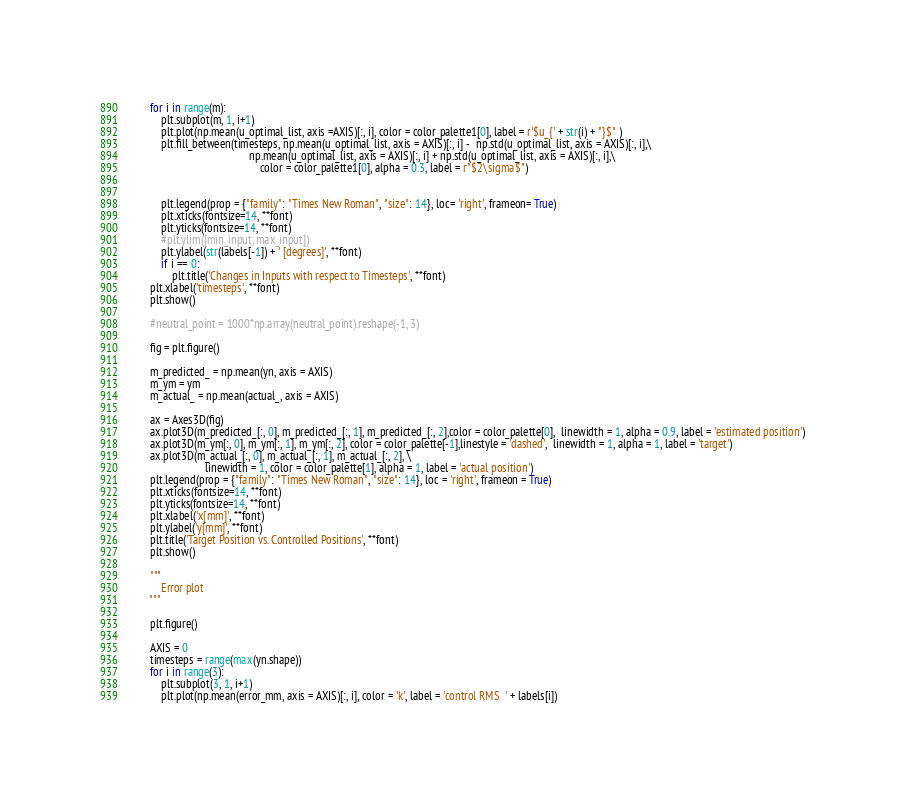Convert code to text. <code><loc_0><loc_0><loc_500><loc_500><_Python_>        for i in range(m):
            plt.subplot(m, 1, i+1)
            plt.plot(np.mean(u_optimal_list, axis =AXIS)[:, i], color = color_palette1[0], label = r'$u_{' + str(i) + "}$" )
            plt.fill_between(timesteps, np.mean(u_optimal_list, axis = AXIS)[:, i] -  np.std(u_optimal_list, axis = AXIS)[:, i],\
                                            np.mean(u_optimal_list, axis = AXIS)[:, i] + np.std(u_optimal_list, axis = AXIS)[:, i],\
                                                color = color_palette1[0], alpha = 0.3, label = r"$2\sigma$")


            plt.legend(prop = {"family": "Times New Roman", "size": 14}, loc= 'right', frameon= True)
            plt.xticks(fontsize=14, **font)
            plt.yticks(fontsize=14, **font)
            #plt.ylim([min_input, max_input])
            plt.ylabel(str(labels[-1]) + ' [degrees]', **font)
            if i == 0:
                plt.title('Changes in Inputs with respect to Timesteps', **font)
        plt.xlabel('timesteps', **font)
        plt.show()

        #neutral_point = 1000*np.array(neutral_point).reshape(-1, 3)

        fig = plt.figure()

        m_predicted_ = np.mean(yn, axis = AXIS)
        m_ym = ym
        m_actual_ = np.mean(actual_, axis = AXIS)

        ax = Axes3D(fig)
        ax.plot3D(m_predicted_[:, 0], m_predicted_[:, 1], m_predicted_[:, 2],color = color_palette[0],  linewidth = 1, alpha = 0.9, label = 'estimated position')
        ax.plot3D(m_ym[:, 0], m_ym[:, 1], m_ym[:, 2], color = color_palette[-1],linestyle = 'dashed',  linewidth = 1, alpha = 1, label = 'target')
        ax.plot3D(m_actual_[:, 0], m_actual_[:, 1], m_actual_[:, 2], \
                            linewidth = 1, color = color_palette[1], alpha = 1, label = 'actual position')
        plt.legend(prop = {"family": "Times New Roman", "size": 14}, loc = 'right', frameon = True)
        plt.xticks(fontsize=14, **font)
        plt.yticks(fontsize=14, **font)
        plt.xlabel('x[mm]', **font)
        plt.ylabel('y[mm]', **font)
        plt.title('Target Position vs. Controlled Positions', **font)
        plt.show()

        """
            Error plot
        """

        plt.figure()

        AXIS = 0
        timesteps = range(max(yn.shape))
        for i in range(3):
            plt.subplot(3, 1, i+1)
            plt.plot(np.mean(error_mm, axis = AXIS)[:, i], color = 'k', label = 'control RMS  ' + labels[i])</code> 